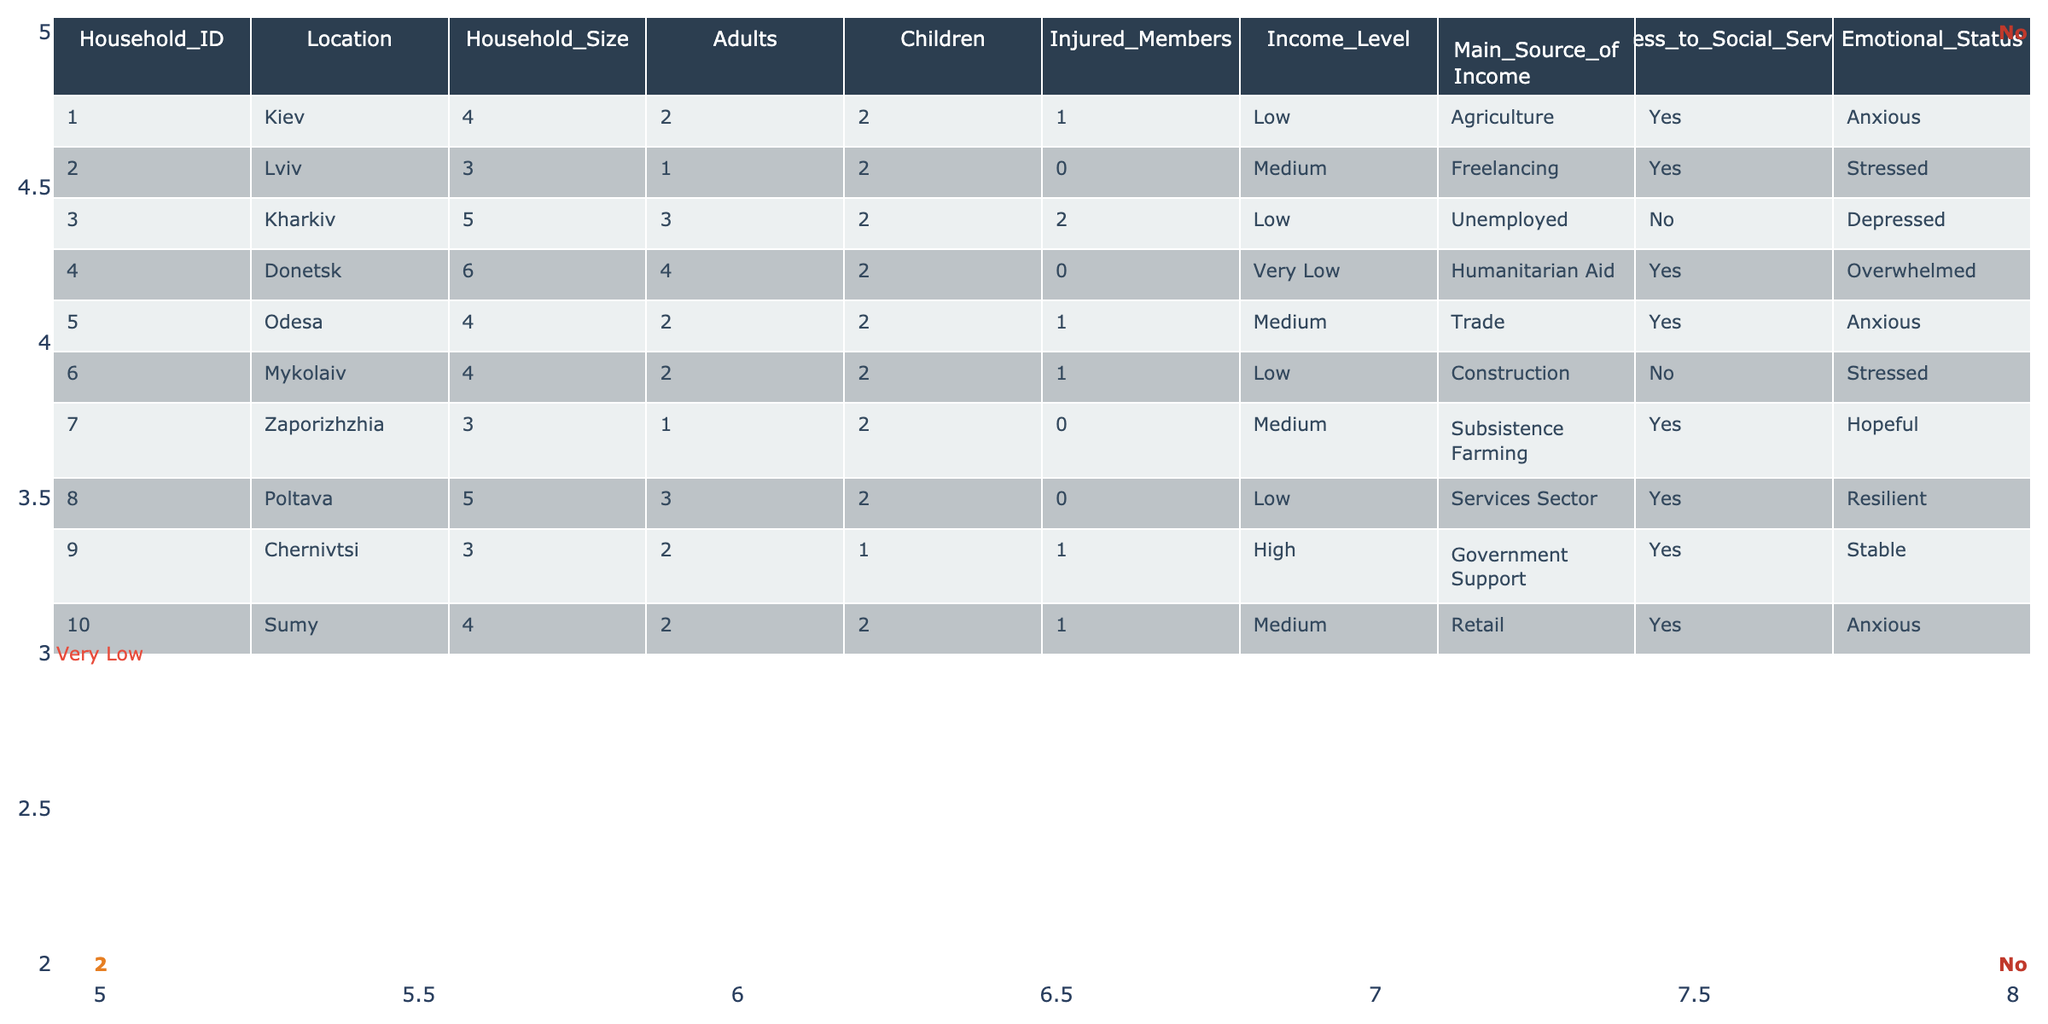What is the location of the household with the highest number of injured members? The household with the highest number of injured members is Household_ID 3, which is in Kharkiv, where there are 2 injured members.
Answer: Kharkiv What is the average household size among the households listed? To find the average household size, add the household sizes (4 + 3 + 5 + 6 + 4 + 4 + 3 + 5 + 3 + 4) = 45. There are 10 households, so the average is 45 / 10 = 4.5.
Answer: 4.5 How many households have access to social services? In the table, 7 out of 10 households have access to social services, as indicated in the Access_to_Social_Services column.
Answer: 7 Which income level has the most households and how many are there? The income level 'Medium' appears 4 times in the table (Household IDs 2, 5, 7, and 10), indicating it has the most households.
Answer: Medium, 4 How many children are there in total for households with very low income? Only one household (Household_ID 4 in Donetsk) has a very low income, which has 2 children. Thus, the total number of children for very low income households is 2.
Answer: 2 Does Household_ID 6 have access to social services? According to the table, Household_ID 6 does not have access to social services, as indicated by 'No' in the Access_to_Social_Services column.
Answer: No What is the emotional status of the household with the largest income level? Household_ID 9 in Chernivtsi has the highest income level of 'High' and its emotional status is 'Stable', as per the Emotional_Status column.
Answer: Stable Which location has the household with the highest emotional status and what is that status? The location with the highest emotional status is Zaporizhzhia, where Household_ID 7 has the status 'Hopeful'.
Answer: Zaporizhzhia, Hopeful What percentage of households have members who are injured? There are 5 households with injured members (Households 1, 3, 4, 5, and 6). Thus, the percentage is (5/10) * 100 = 50%.
Answer: 50% Is there any household with an income level of 'Very Low' that does not have injured members? Yes, there is one household (Household_ID 4) with an income level of 'Very Low' but it has 0 injured members.
Answer: Yes 